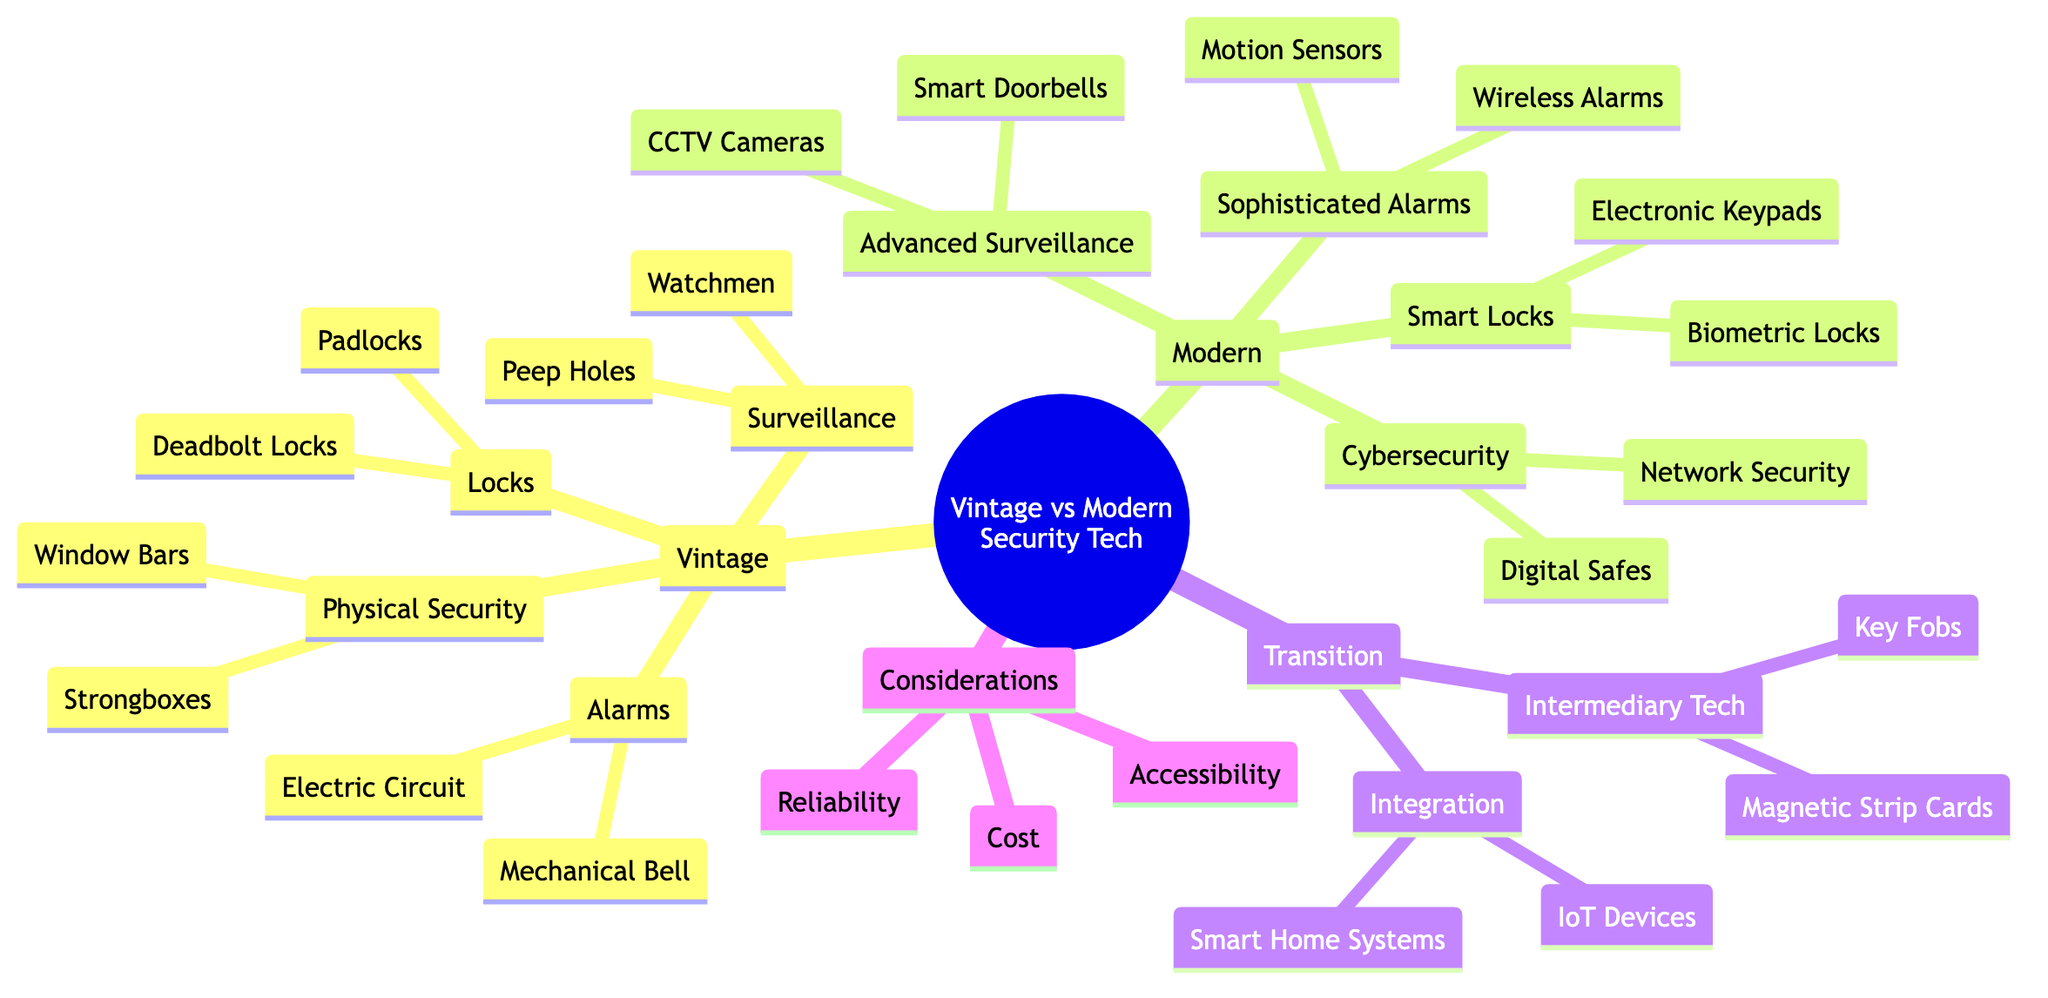What are two types of vintage locks mentioned? The mind map shows "Padlocks" and "Deadbolt Locks" under the "Locks" category for "Vintage Security Technologies." These are specifically listed as two types of locks.
Answer: Padlocks, Deadbolt Locks How many types of alarms are listed under modern security technologies? The diagram categorizes "Sophisticated Alarms" under "Modern Security Technologies" and lists two types: "Wireless Alarms" and "Motion Sensors." Thus, there are two types.
Answer: 2 What is a major benefit of vintage systems compared to modern systems regarding reliability? The mind map states that vintage systems are "Mechanical reliability, less prone to hacking," while modern systems rely on internet and electricity, which increases complexity. This indicates that vintage systems have a reliability advantage.
Answer: Mechanical reliability What links "Smart Home Systems" and "IoT Devices" in the diagram? "Smart Home Systems" and "IoT Devices" are under the "Integration" category where they relate to the transition from vintage to modern technologies. They are connected by being part of the interoperability in modern security technologies.
Answer: Integration What is the primary advantage mentioned for modern systems over vintage systems in terms of accessibility? The diagram indicates that modern systems offer "Remote access, app-based control," giving a significant advantage in terms of ease of access compared to vintage systems.
Answer: Remote access Which category includes both "CCTV Cameras" and "Smart Doorbells"? Both "CCTV Cameras" and "Smart Doorbells" are included under the "Advanced Surveillance" category in the modern security technologies section of the mind map.
Answer: Advanced Surveillance What feature distinguishes biometric locks from electronic keypads in modern security technology? The mind map describes "Biometric Locks" as using "Fingerprint and facial recognition systems," while "Electronic Keypads" allow access through code entry, highlighting the advanced identification method in biometric locks.
Answer: Fingerprint, facial recognition What are the intermediary technologies mentioned related to security systems? Under the "Intermediary Technologies" category, the diagram lists "Magnetic Strip Cards" and "Key Fobs," which are both forms of access technology that bridge vintage and modern systems.
Answer: Magnetic Strip Cards, Key Fobs How does the cost of vintage systems compare to modern systems based on the diagram? The mind map specifies that vintage systems have a "Lower initial cost, less maintenance needed," while modern systems have "Higher upfront cost, ongoing updates and maintenance," indicating a cost advantage for vintage systems.
Answer: Lower initial cost 